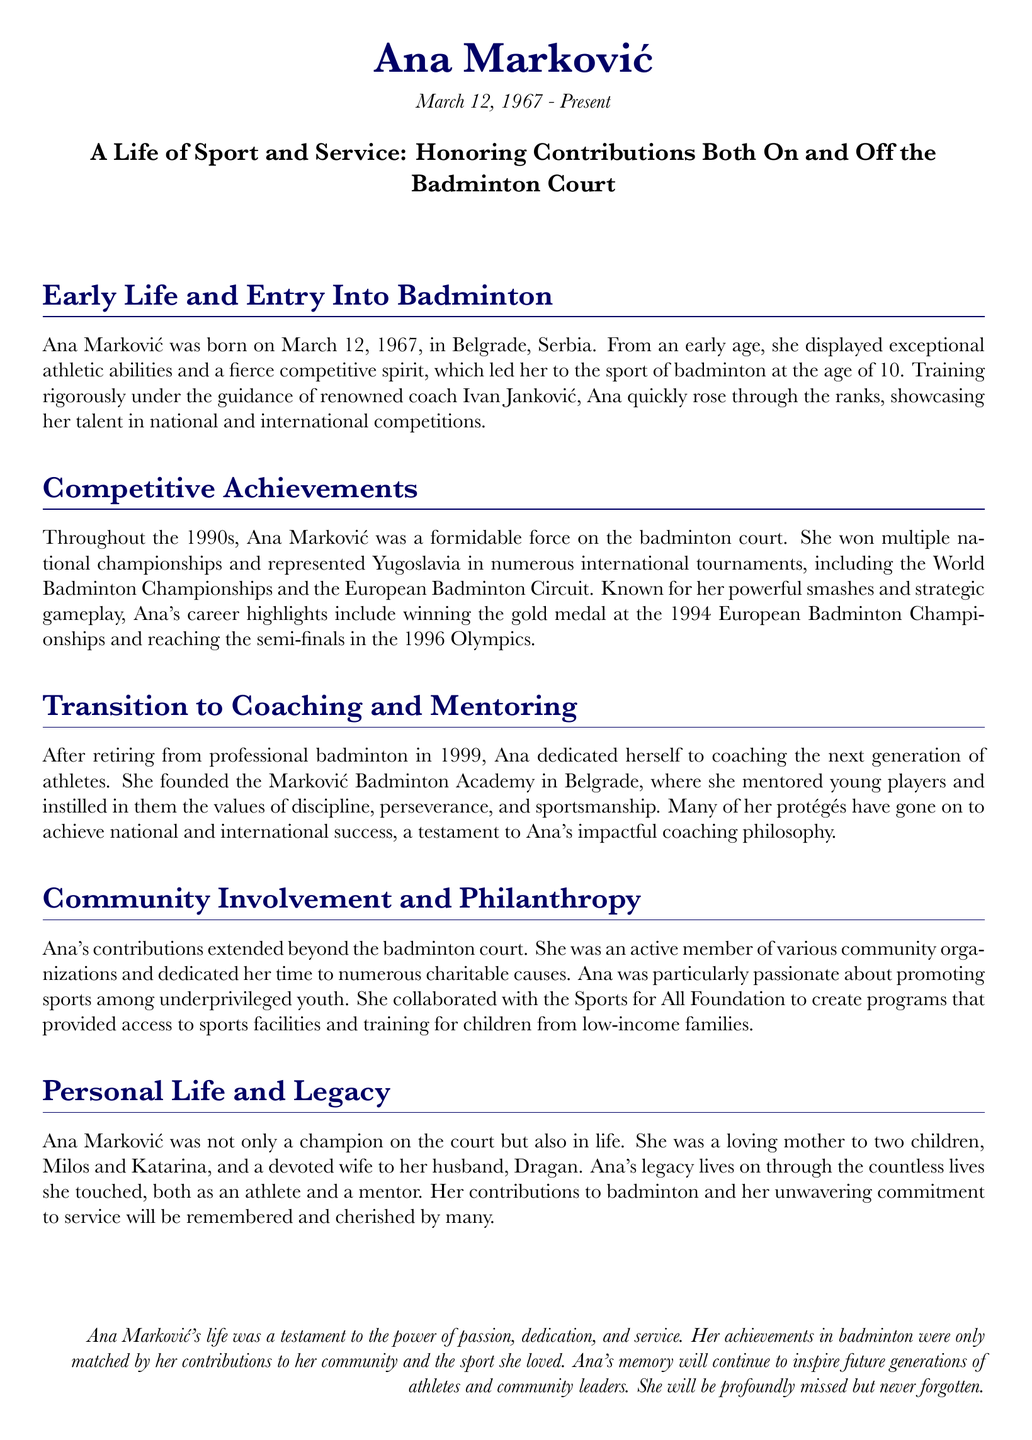What is Ana Marković's birth date? The document states that Ana Marković was born on March 12, 1967.
Answer: March 12, 1967 What city was Ana Marković born in? The document mentions that Ana was born in Belgrade, Serbia.
Answer: Belgrade What major sports event did Ana Marković reach the semi-finals in? The document indicates she reached the semi-finals in the 1996 Olympics.
Answer: 1996 Olympics How many children did Ana Marković have? The document states she was a loving mother to two children, Milos and Katarina.
Answer: Two What was the name of Ana Marković's badminton academy? The document mentions she founded the Marković Badminton Academy.
Answer: Marković Badminton Academy In which year did Ana retire from professional badminton? The document notes that she retired in 1999.
Answer: 1999 What was Ana Marković passionate about in her community work? The document states she was particularly passionate about promoting sports among underprivileged youth.
Answer: Promoting sports among underprivileged youth What did Ana instill in her protégés? The document indicates that she instilled the values of discipline, perseverance, and sportsmanship.
Answer: Discipline, perseverance, and sportsmanship What was Ana Marković's legacy described as? The document describes her legacy as a testament to the power of passion, dedication, and service.
Answer: A testament to the power of passion, dedication, and service 